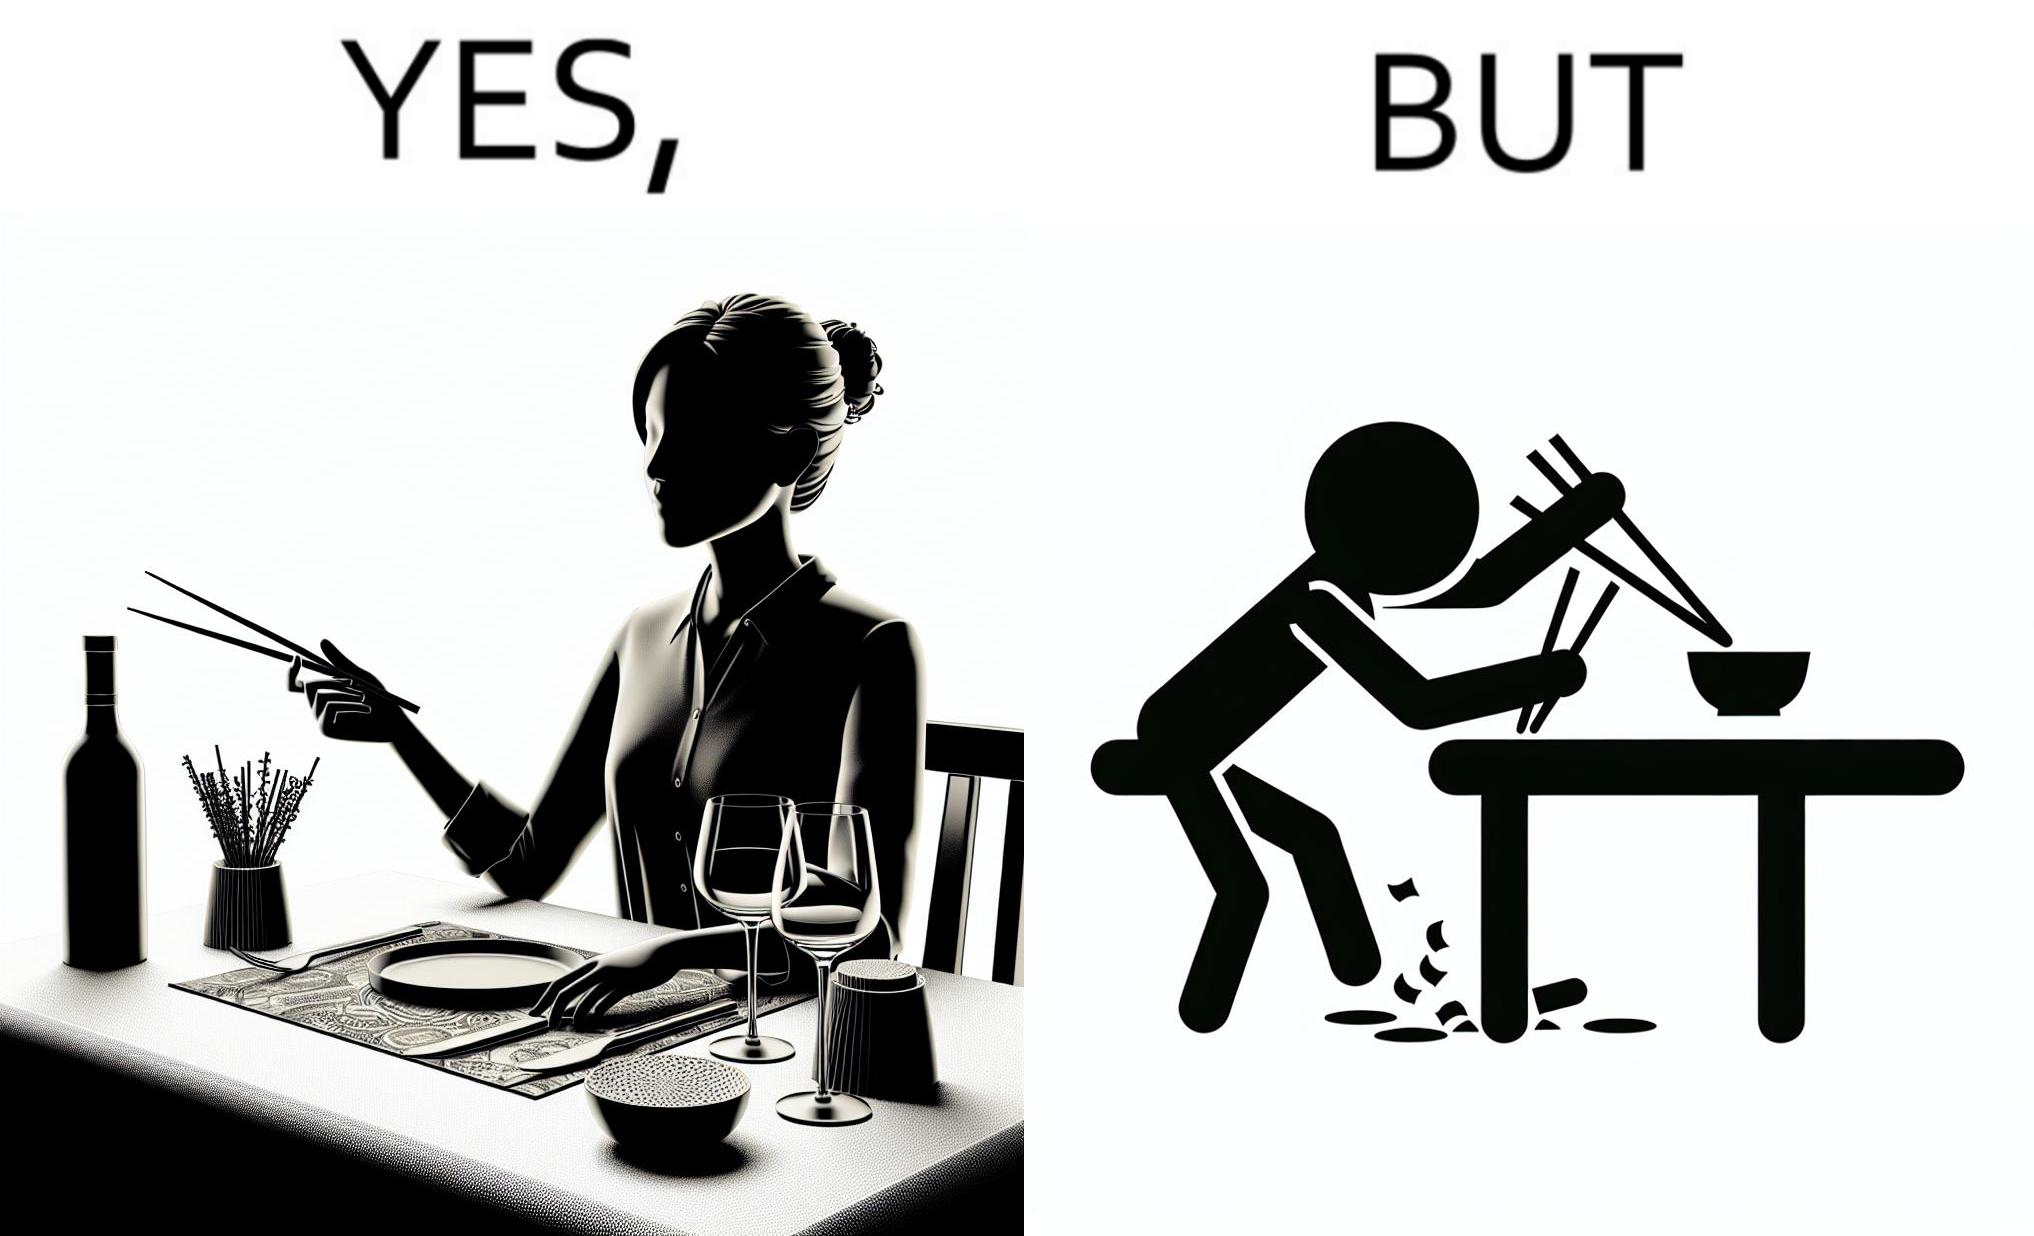Does this image contain satire or humor? Yes, this image is satirical. 